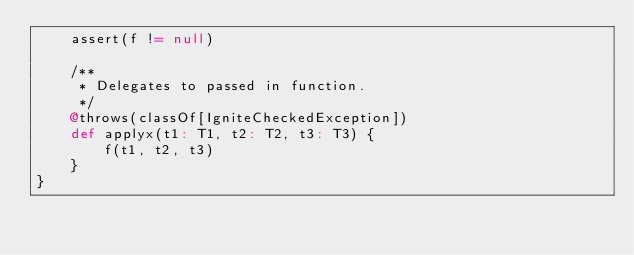<code> <loc_0><loc_0><loc_500><loc_500><_Scala_>    assert(f != null)

    /**
     * Delegates to passed in function.
     */
    @throws(classOf[IgniteCheckedException])
    def applyx(t1: T1, t2: T2, t3: T3) {
        f(t1, t2, t3)
    }
}
</code> 